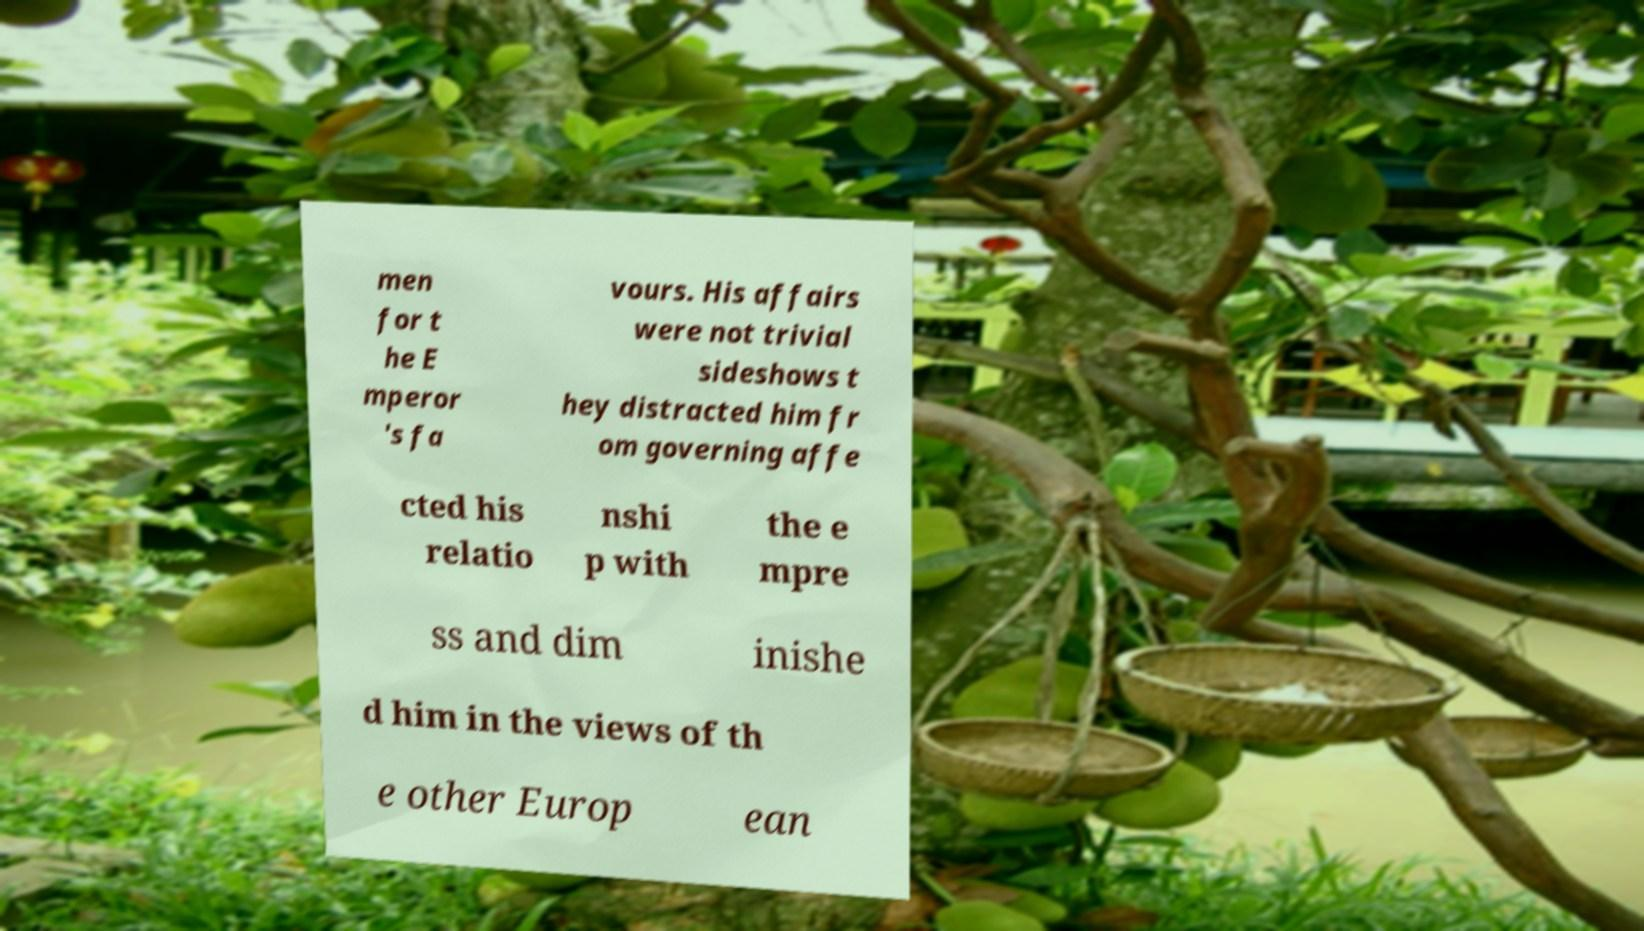There's text embedded in this image that I need extracted. Can you transcribe it verbatim? men for t he E mperor 's fa vours. His affairs were not trivial sideshows t hey distracted him fr om governing affe cted his relatio nshi p with the e mpre ss and dim inishe d him in the views of th e other Europ ean 